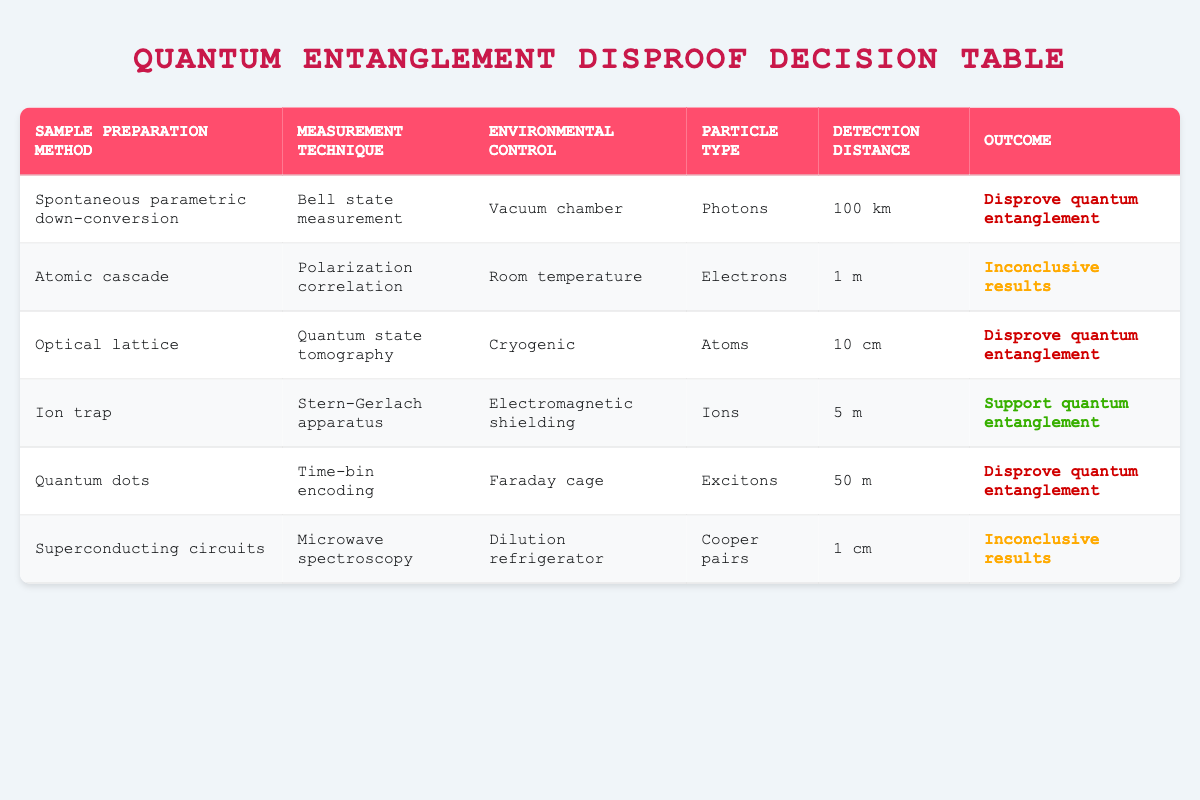What sample preparation method was used to disprove quantum entanglement with photons? In the table, there are two rows where the outcome indicates "Disprove quantum entanglement." One relates to photons using "Spontaneous parametric down-conversion," while the other concerns excitons using "Quantum dots." Hence, the method associated with disproving it for photons is "Spontaneous parametric down-conversion."
Answer: Spontaneous parametric down-conversion How many different measurement techniques are listed in the table? The measurement techniques in the table include: Bell state measurement, Polarization correlation, Quantum state tomography, Stern-Gerlach apparatus, Time-bin encoding, and Microwave spectroscopy. There are six unique techniques. To verify, we count each once regardless of duplicates.
Answer: 6 Is there any entry using cryogenic environmental control that results in conclusive evidence against quantum entanglement? The table lists one relevant entry with "Cryogenic" under environmental control, which is related to atoms and employs quantum state tomography. The outcome states "Disprove quantum entanglement." Therefore, the answer is yes.
Answer: Yes What is the detection distance for the entry using ion trap and what was the outcome? In the table, the row for "Ion trap" specifies a detection distance of "5 m" and the outcome as "Support quantum entanglement." Thus, I can provide both the detection distance and outcome together.
Answer: 5 m, Support quantum entanglement Determine the average detection distance for outcomes that resulted in inconclusive results. There are two entries yielding inconclusive results: one for "1 m" related to atomic cascade and the other "1 cm" for superconducting circuits. To find the average, first, convert 1 m to cm for consistency: 1 m = 100 cm. Thus, we sum 100 cm + 1 cm = 101 cm, and divide by 2 to get the average: 101 cm / 2 = 50.5 cm.
Answer: 50.5 cm What are the particle types associated with disapproving quantum entanglement at the highest detection distance? In the table, three entries "Disprove quantum entanglement," the highest detection distance noted is "100 km" with photons mentioned. The other entries have shorter distances: atoms at 10 cm and excitons at 50 m. Therefore, the particle type connected to the highest distance disapproving it is photons.
Answer: Photons Which measurement technique has been used under room temperature conditions, and what was the outcome? The row with "Room temperature" specifies that the measurement technique used was "Polarization correlation." Its outcome indicated "Inconclusive results." Thus, I can identify both the technique and the corresponding outcome clearly.
Answer: Polarization correlation, inconclusive results Is there any situation where the outcome is "Inconclusive results" with a detection distance less than 2 m? The table shows two entries with inconclusive results, one with detection at "1 m" and the other at "1 cm." Both are indeed below 2 m. Hence, there are situations confirming this outcome.
Answer: Yes 